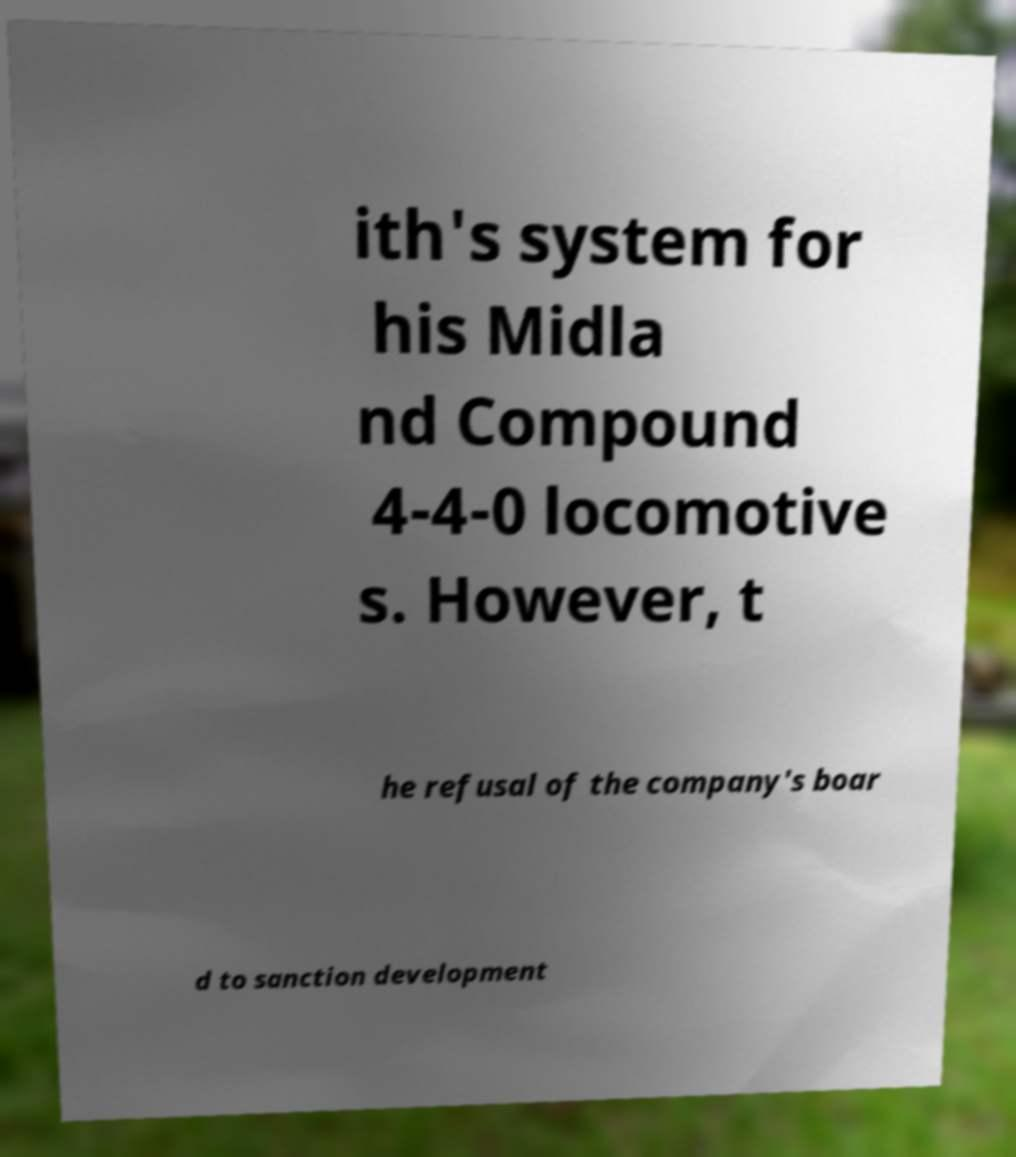Please read and relay the text visible in this image. What does it say? ith's system for his Midla nd Compound 4-4-0 locomotive s. However, t he refusal of the company's boar d to sanction development 